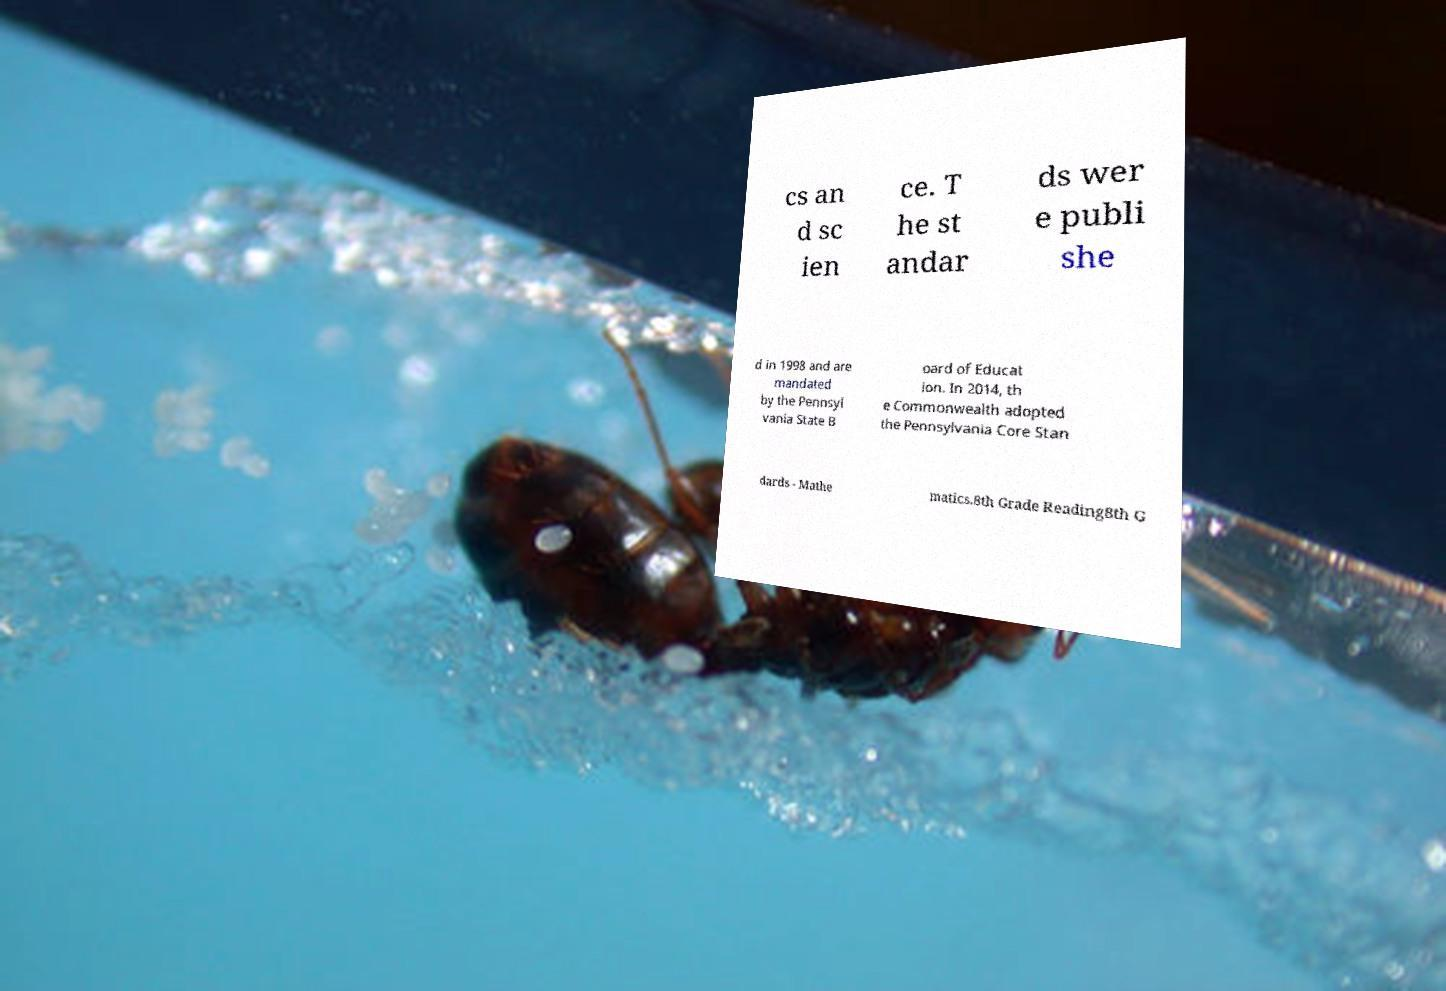What messages or text are displayed in this image? I need them in a readable, typed format. cs an d sc ien ce. T he st andar ds wer e publi she d in 1998 and are mandated by the Pennsyl vania State B oard of Educat ion. In 2014, th e Commonwealth adopted the Pennsylvania Core Stan dards - Mathe matics.8th Grade Reading8th G 